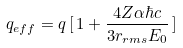<formula> <loc_0><loc_0><loc_500><loc_500>q _ { e f f } = q \, [ \, 1 + \frac { 4 Z \alpha \hbar { c } } { 3 r _ { r m s } E _ { 0 } } \, ]</formula> 